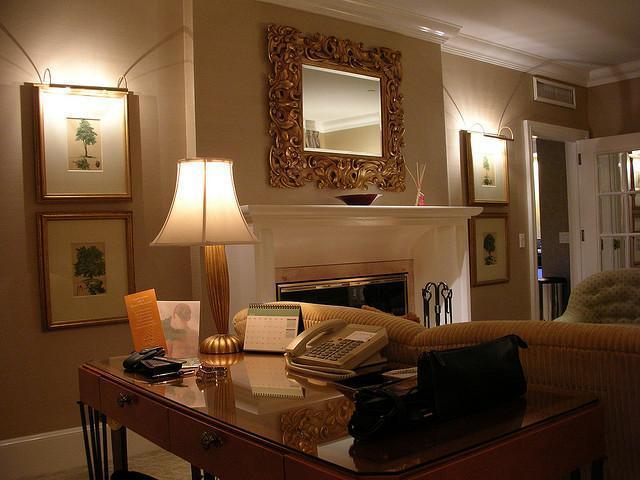How many handbags can you see?
Give a very brief answer. 2. How many couches are there?
Give a very brief answer. 2. How many sinks are in this room?
Give a very brief answer. 0. 